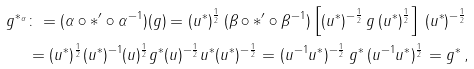<formula> <loc_0><loc_0><loc_500><loc_500>g ^ { * _ { \alpha } } & \colon = ( \alpha \circ * ^ { \prime } \circ \alpha ^ { - 1 } ) ( g ) = ( u ^ { * } ) ^ { \frac { 1 } { 2 } } \, ( \beta \circ * ^ { \prime } \circ \beta ^ { - 1 } ) \left [ ( u ^ { * } ) ^ { - \frac { 1 } { 2 } } \, g \, ( u ^ { * } ) ^ { \frac { 1 } { 2 } } \right ] \, ( u ^ { * } ) ^ { - \frac { 1 } { 2 } } \\ & = ( u ^ { * } ) ^ { \frac { 1 } { 2 } } ( u ^ { * } ) ^ { - 1 } ( u ) ^ { \frac { 1 } { 2 } } g ^ { * } ( u ) ^ { - \frac { 1 } { 2 } } u ^ { * } ( u ^ { * } ) ^ { - \frac { 1 } { 2 } } = ( u ^ { - 1 } u ^ { * } ) ^ { - \frac { 1 } { 2 } } \, g ^ { * } \, ( u ^ { - 1 } u ^ { * } ) ^ { \frac { 1 } { 2 } } = g ^ { * } \, ,</formula> 